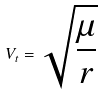<formula> <loc_0><loc_0><loc_500><loc_500>V _ { t } = \sqrt { \frac { \mu } { r } }</formula> 